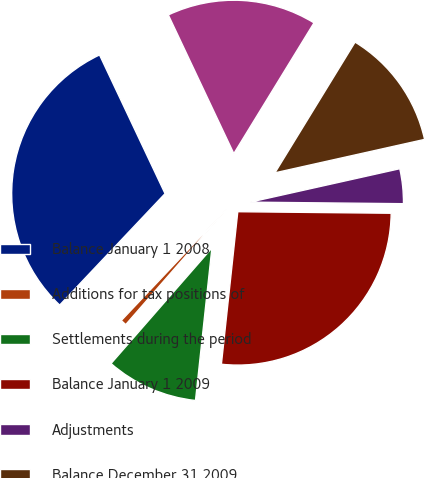Convert chart to OTSL. <chart><loc_0><loc_0><loc_500><loc_500><pie_chart><fcel>Balance January 1 2008<fcel>Additions for tax positions of<fcel>Settlements during the period<fcel>Balance January 1 2009<fcel>Adjustments<fcel>Balance December 31 2009<fcel>Balance December 31 2010<nl><fcel>30.93%<fcel>0.63%<fcel>9.72%<fcel>26.55%<fcel>3.66%<fcel>12.75%<fcel>15.78%<nl></chart> 